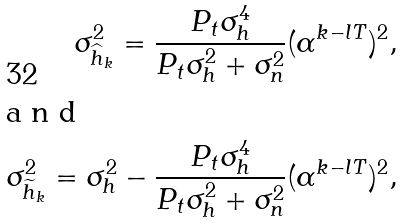Convert formula to latex. <formula><loc_0><loc_0><loc_500><loc_500>\sigma _ { \widehat { h } _ { k } } ^ { 2 } = \frac { P _ { t } \sigma _ { h } ^ { 4 } } { P _ { t } \sigma _ { h } ^ { 2 } + \sigma _ { n } ^ { 2 } } ( \alpha ^ { k - l T } ) ^ { 2 } , \\ \intertext { a n d } \sigma _ { \widetilde { h } _ { k } } ^ { 2 } = \sigma _ { h } ^ { 2 } - \frac { P _ { t } \sigma _ { h } ^ { 4 } } { P _ { t } \sigma _ { h } ^ { 2 } + \sigma _ { n } ^ { 2 } } ( \alpha ^ { k - l T } ) ^ { 2 } ,</formula> 